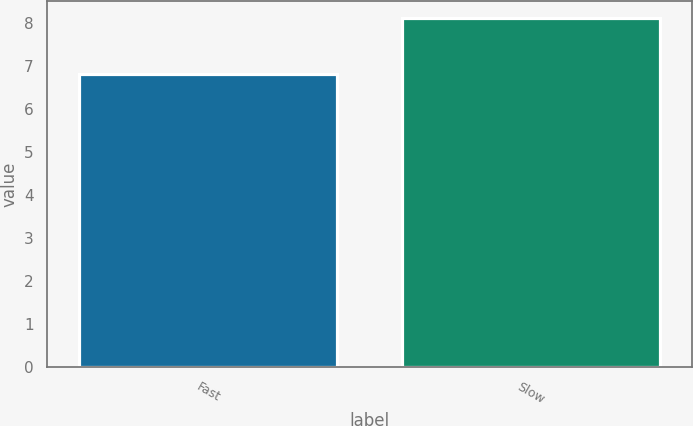Convert chart to OTSL. <chart><loc_0><loc_0><loc_500><loc_500><bar_chart><fcel>Fast<fcel>Slow<nl><fcel>6.8<fcel>8.1<nl></chart> 